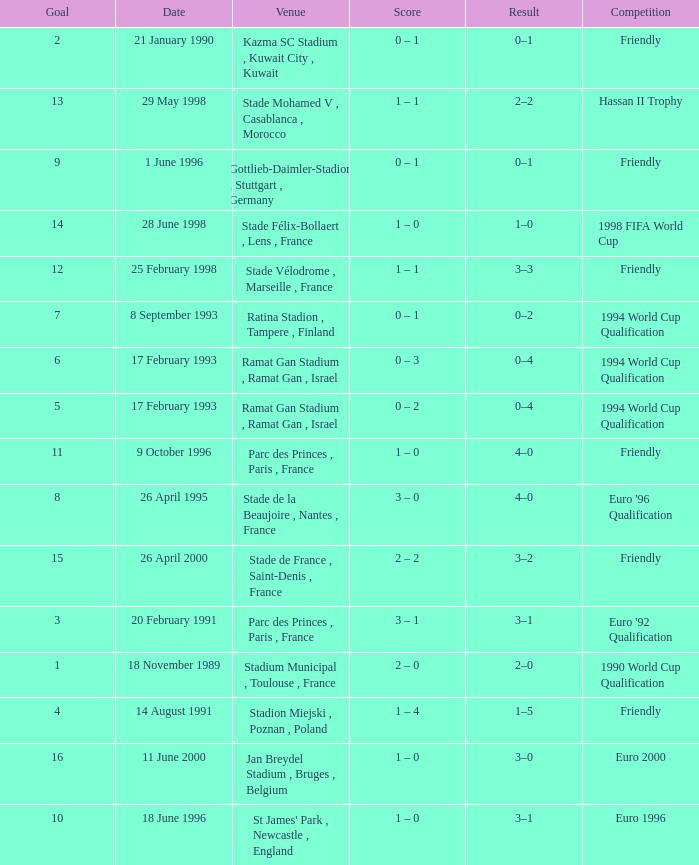What was the date of the game with a goal of 7? 8 September 1993. 